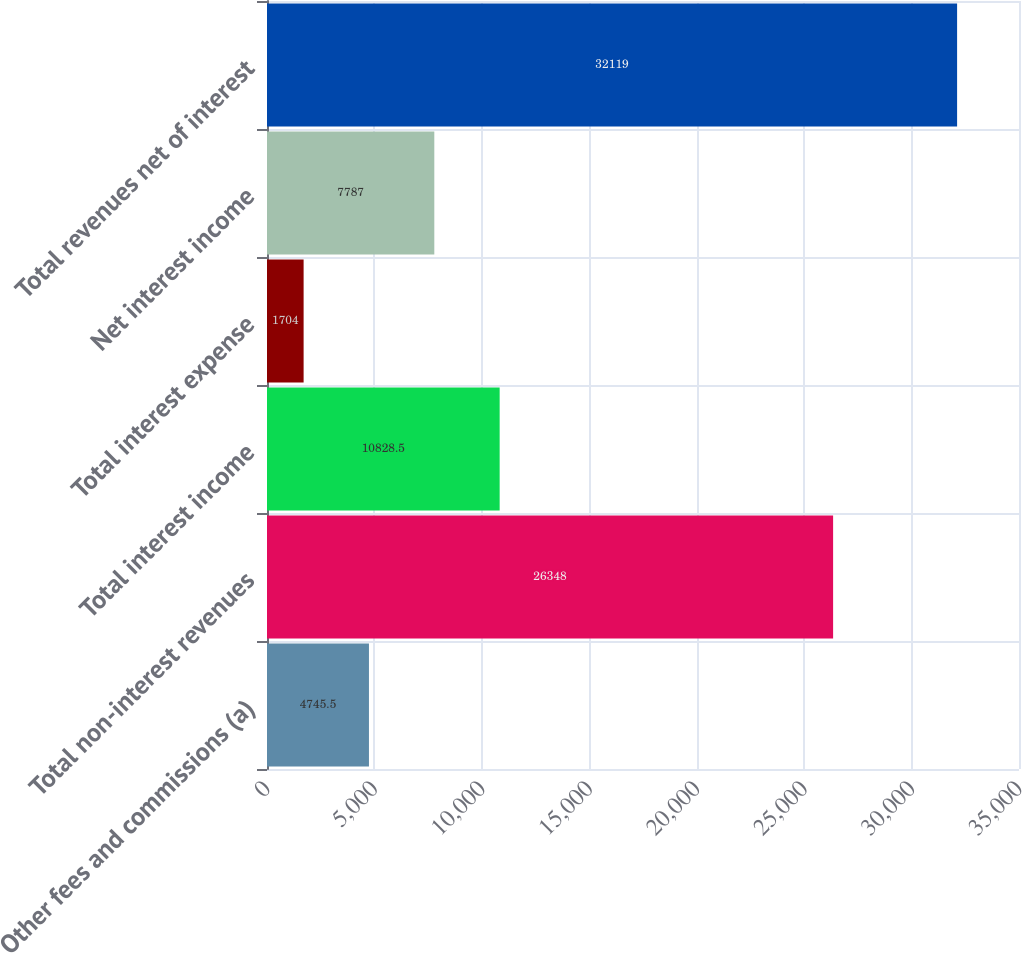Convert chart. <chart><loc_0><loc_0><loc_500><loc_500><bar_chart><fcel>Other fees and commissions (a)<fcel>Total non-interest revenues<fcel>Total interest income<fcel>Total interest expense<fcel>Net interest income<fcel>Total revenues net of interest<nl><fcel>4745.5<fcel>26348<fcel>10828.5<fcel>1704<fcel>7787<fcel>32119<nl></chart> 